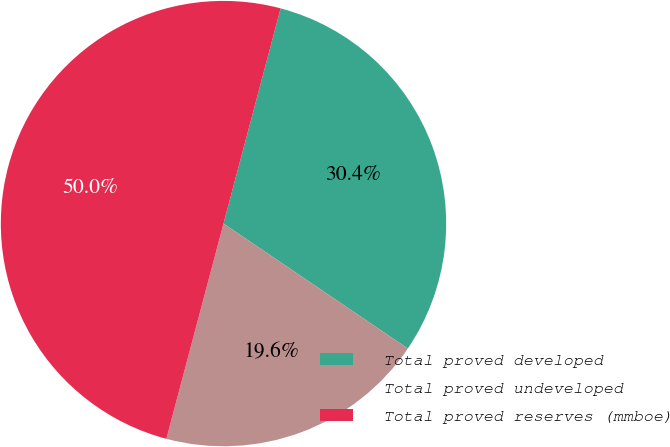Convert chart to OTSL. <chart><loc_0><loc_0><loc_500><loc_500><pie_chart><fcel>Total proved developed<fcel>Total proved undeveloped<fcel>Total proved reserves (mmboe)<nl><fcel>30.35%<fcel>19.65%<fcel>50.0%<nl></chart> 